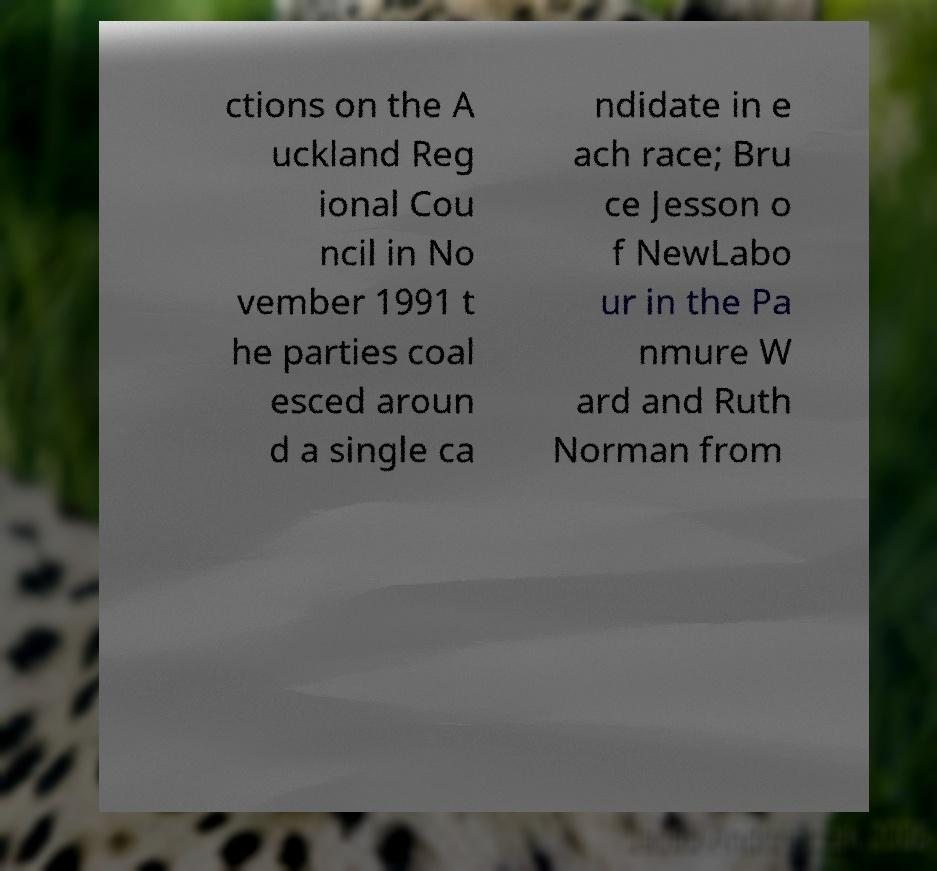Could you extract and type out the text from this image? ctions on the A uckland Reg ional Cou ncil in No vember 1991 t he parties coal esced aroun d a single ca ndidate in e ach race; Bru ce Jesson o f NewLabo ur in the Pa nmure W ard and Ruth Norman from 